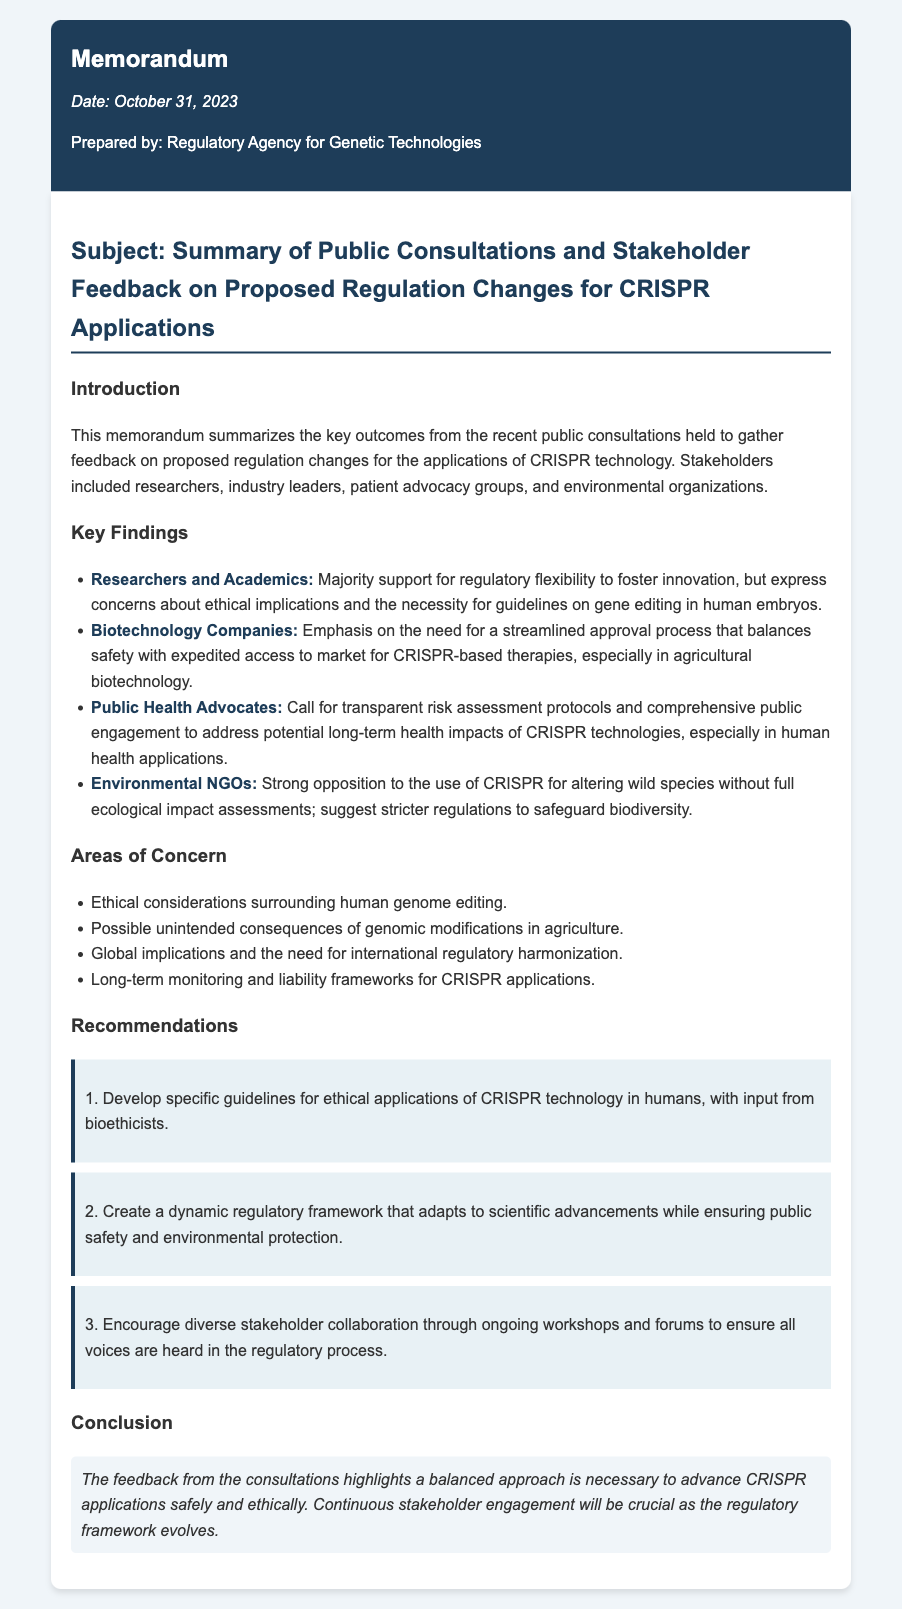what is the title of the memorandum? The title of the memorandum is stated in the subject section.
Answer: Summary of Public Consultations and Stakeholder Feedback on Proposed Regulation Changes for CRISPR Applications who prepared the memorandum? The prepared by line indicates who authored the document.
Answer: Regulatory Agency for Genetic Technologies when was the memorandum prepared? The date prepared is mentioned prominently at the top of the memo.
Answer: October 31, 2023 which stakeholder group expressed concerns about ethical implications? The section under Researchers and Academics mentions their concerns.
Answer: Researchers and Academics what is one area of concern related to genomic modifications in agriculture? The areas of concern section lists possible unintended consequences specifically for agriculture.
Answer: Possible unintended consequences of genomic modifications in agriculture what recommendation involves bioethicists? The recommendations section highlights the need for ethical guidelines.
Answer: Develop specific guidelines for ethical applications of CRISPR technology in humans, with input from bioethicists which stakeholder group requested transparent risk assessment protocols? The corresponding section list identifies this stakeholder group.
Answer: Public Health Advocates what is a suggested measure by Environmental NGOs regarding wild species? The document notes their stance on ecological impact assessments.
Answer: Suggest stricter regulations to safeguard biodiversity 